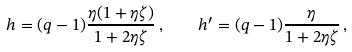Convert formula to latex. <formula><loc_0><loc_0><loc_500><loc_500>h = ( q - 1 ) \frac { \eta ( 1 + \eta \zeta ) } { 1 + 2 \eta \zeta } \, , \quad h ^ { \prime } = ( q - 1 ) \frac { \eta } { 1 + 2 \eta \zeta } \, ,</formula> 